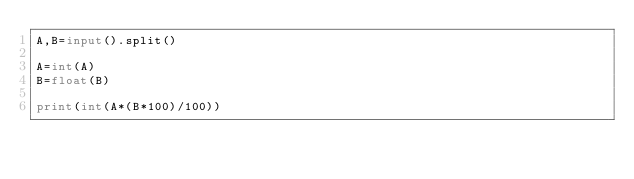Convert code to text. <code><loc_0><loc_0><loc_500><loc_500><_Python_>A,B=input().split()

A=int(A)
B=float(B)

print(int(A*(B*100)/100))</code> 